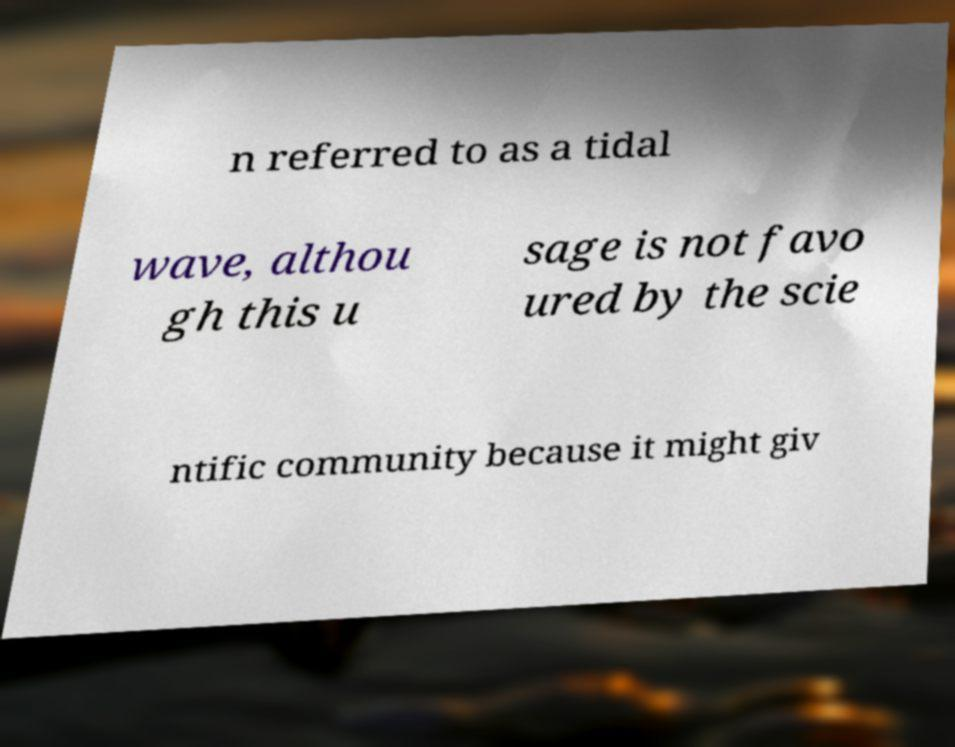Please identify and transcribe the text found in this image. n referred to as a tidal wave, althou gh this u sage is not favo ured by the scie ntific community because it might giv 